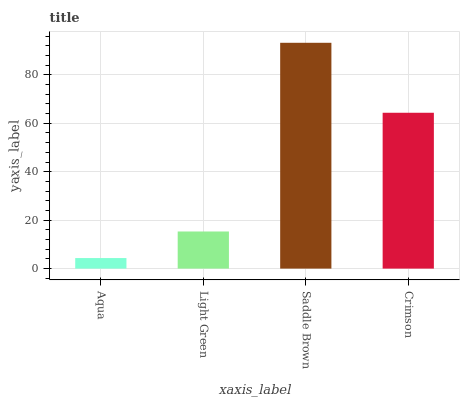Is Aqua the minimum?
Answer yes or no. Yes. Is Saddle Brown the maximum?
Answer yes or no. Yes. Is Light Green the minimum?
Answer yes or no. No. Is Light Green the maximum?
Answer yes or no. No. Is Light Green greater than Aqua?
Answer yes or no. Yes. Is Aqua less than Light Green?
Answer yes or no. Yes. Is Aqua greater than Light Green?
Answer yes or no. No. Is Light Green less than Aqua?
Answer yes or no. No. Is Crimson the high median?
Answer yes or no. Yes. Is Light Green the low median?
Answer yes or no. Yes. Is Saddle Brown the high median?
Answer yes or no. No. Is Saddle Brown the low median?
Answer yes or no. No. 